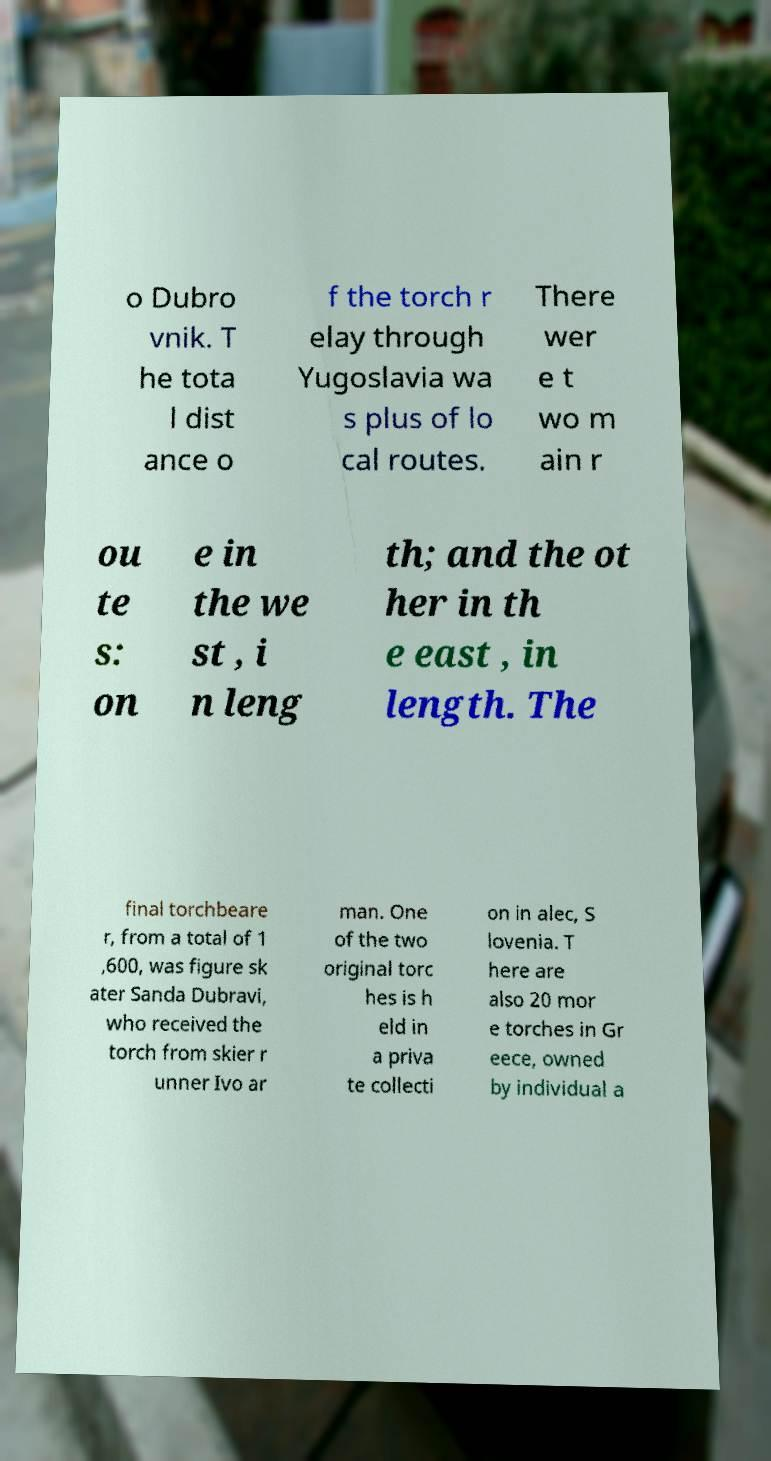I need the written content from this picture converted into text. Can you do that? o Dubro vnik. T he tota l dist ance o f the torch r elay through Yugoslavia wa s plus of lo cal routes. There wer e t wo m ain r ou te s: on e in the we st , i n leng th; and the ot her in th e east , in length. The final torchbeare r, from a total of 1 ,600, was figure sk ater Sanda Dubravi, who received the torch from skier r unner Ivo ar man. One of the two original torc hes is h eld in a priva te collecti on in alec, S lovenia. T here are also 20 mor e torches in Gr eece, owned by individual a 